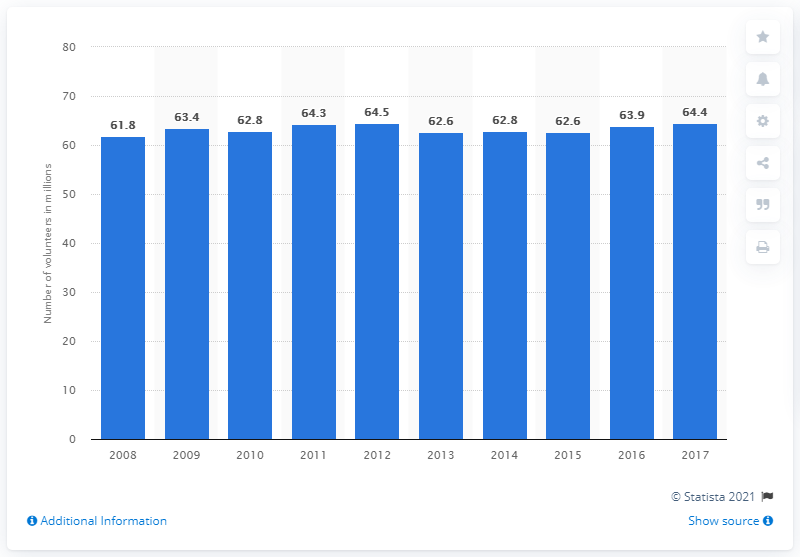Outline some significant characteristics in this image. In 2017, approximately 64.4% of Americans volunteered in the United States. 